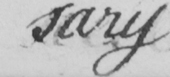Can you tell me what this handwritten text says? sary 